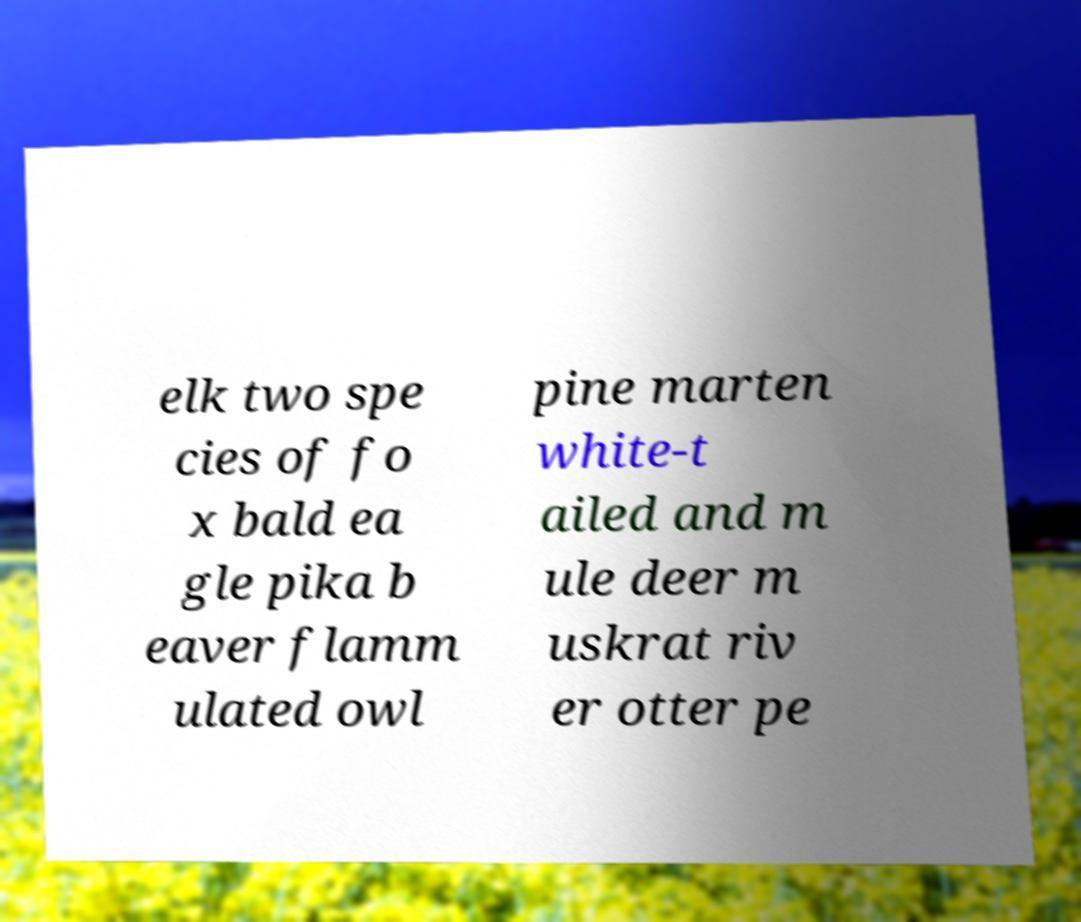I need the written content from this picture converted into text. Can you do that? elk two spe cies of fo x bald ea gle pika b eaver flamm ulated owl pine marten white-t ailed and m ule deer m uskrat riv er otter pe 